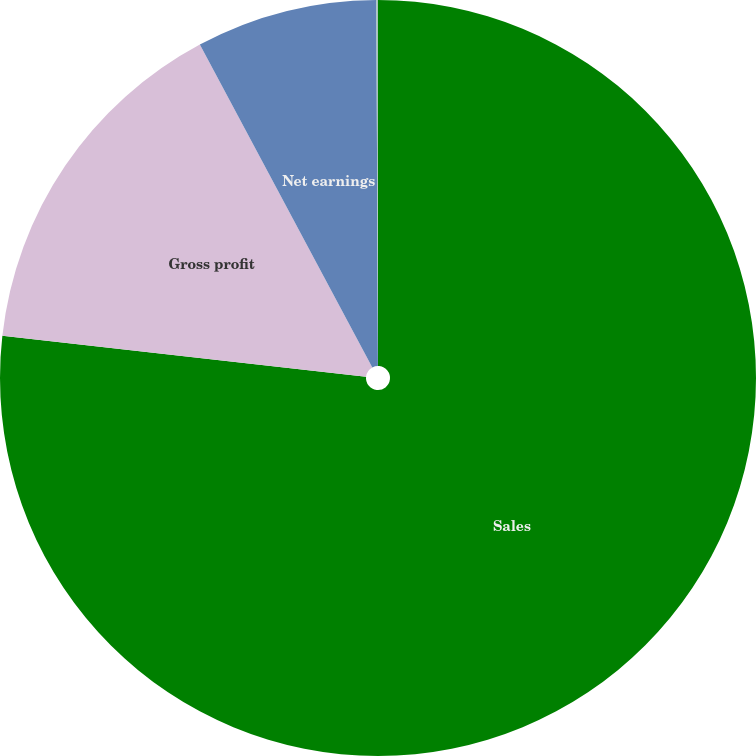Convert chart. <chart><loc_0><loc_0><loc_500><loc_500><pie_chart><fcel>Sales<fcel>Gross profit<fcel>Net earnings<fcel>Share of earnings from equity<nl><fcel>76.77%<fcel>15.41%<fcel>7.74%<fcel>0.07%<nl></chart> 